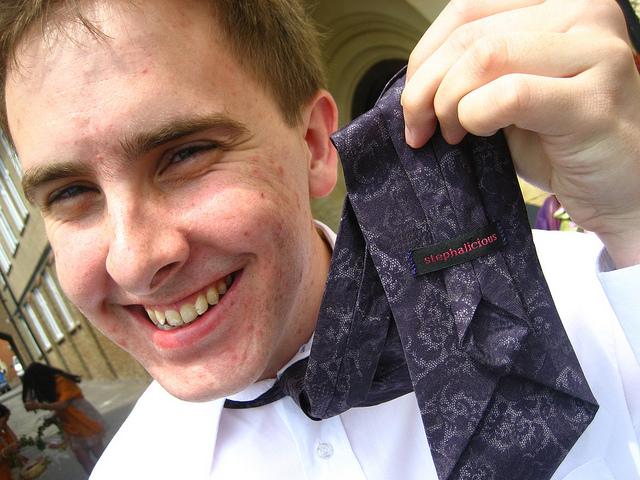What brand is the tie?
Answer briefly. Stephalicious. What is this man showing off?
Answer briefly. Tie. How many people in the shot?
Write a very short answer. 1. 